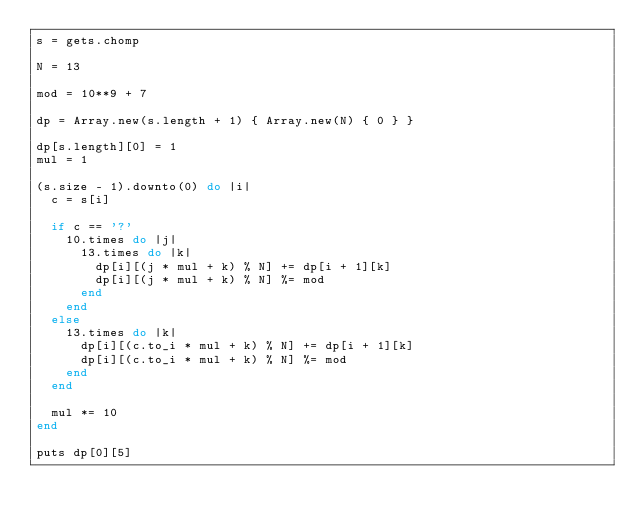Convert code to text. <code><loc_0><loc_0><loc_500><loc_500><_Ruby_>s = gets.chomp

N = 13

mod = 10**9 + 7

dp = Array.new(s.length + 1) { Array.new(N) { 0 } }

dp[s.length][0] = 1
mul = 1

(s.size - 1).downto(0) do |i|
  c = s[i]

  if c == '?'
    10.times do |j|
      13.times do |k|
        dp[i][(j * mul + k) % N] += dp[i + 1][k]
        dp[i][(j * mul + k) % N] %= mod
      end
    end
  else
    13.times do |k|
      dp[i][(c.to_i * mul + k) % N] += dp[i + 1][k]
      dp[i][(c.to_i * mul + k) % N] %= mod
    end
  end

  mul *= 10
end

puts dp[0][5]
</code> 